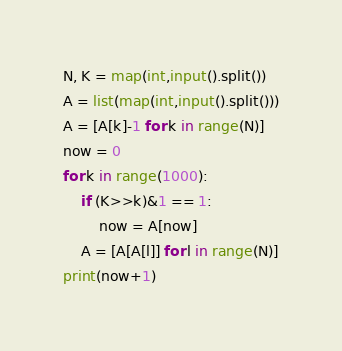Convert code to text. <code><loc_0><loc_0><loc_500><loc_500><_Python_>N, K = map(int,input().split())
A = list(map(int,input().split()))
A = [A[k]-1 for k in range(N)]
now = 0
for k in range(1000):
    if (K>>k)&1 == 1:
        now = A[now]
    A = [A[A[l]] for l in range(N)]
print(now+1)
</code> 